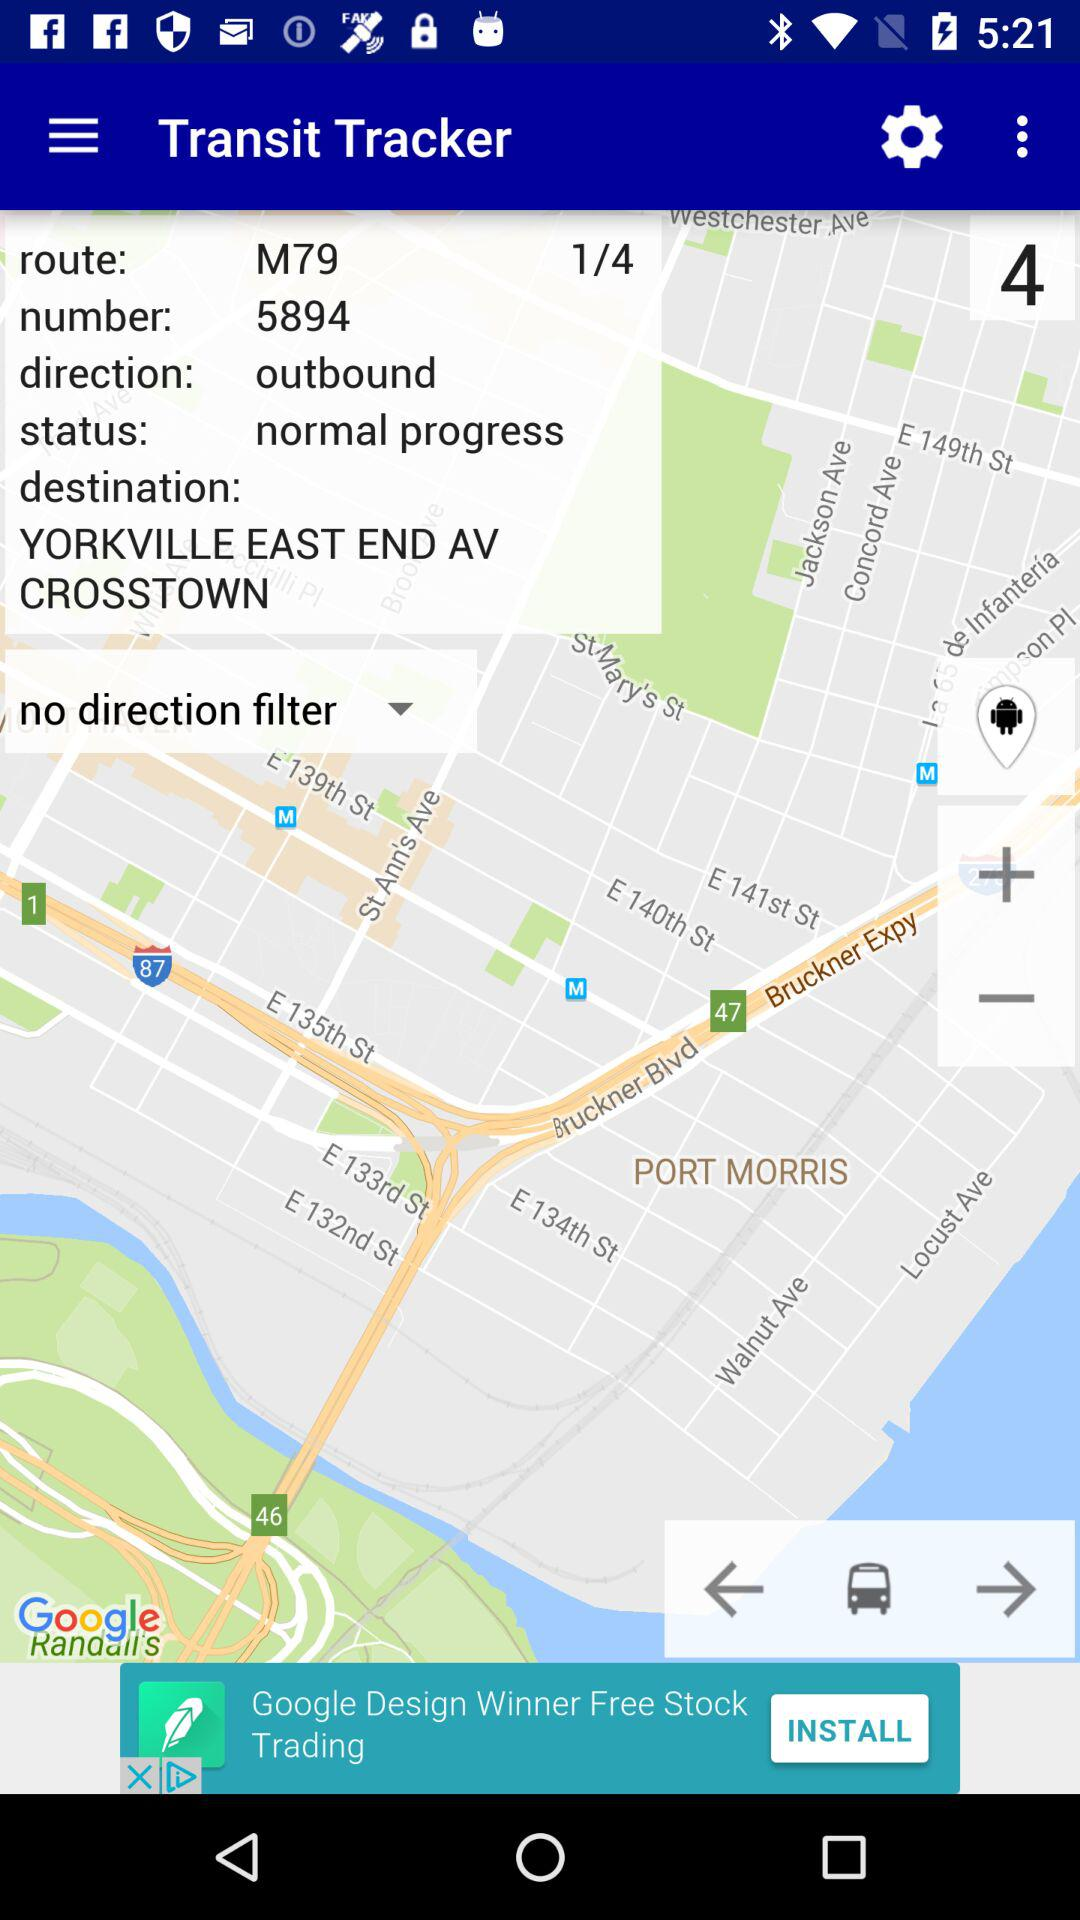What is the given direction? The given direction is outbound. 